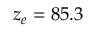Convert formula to latex. <formula><loc_0><loc_0><loc_500><loc_500>z _ { e } = 8 5 . 3</formula> 